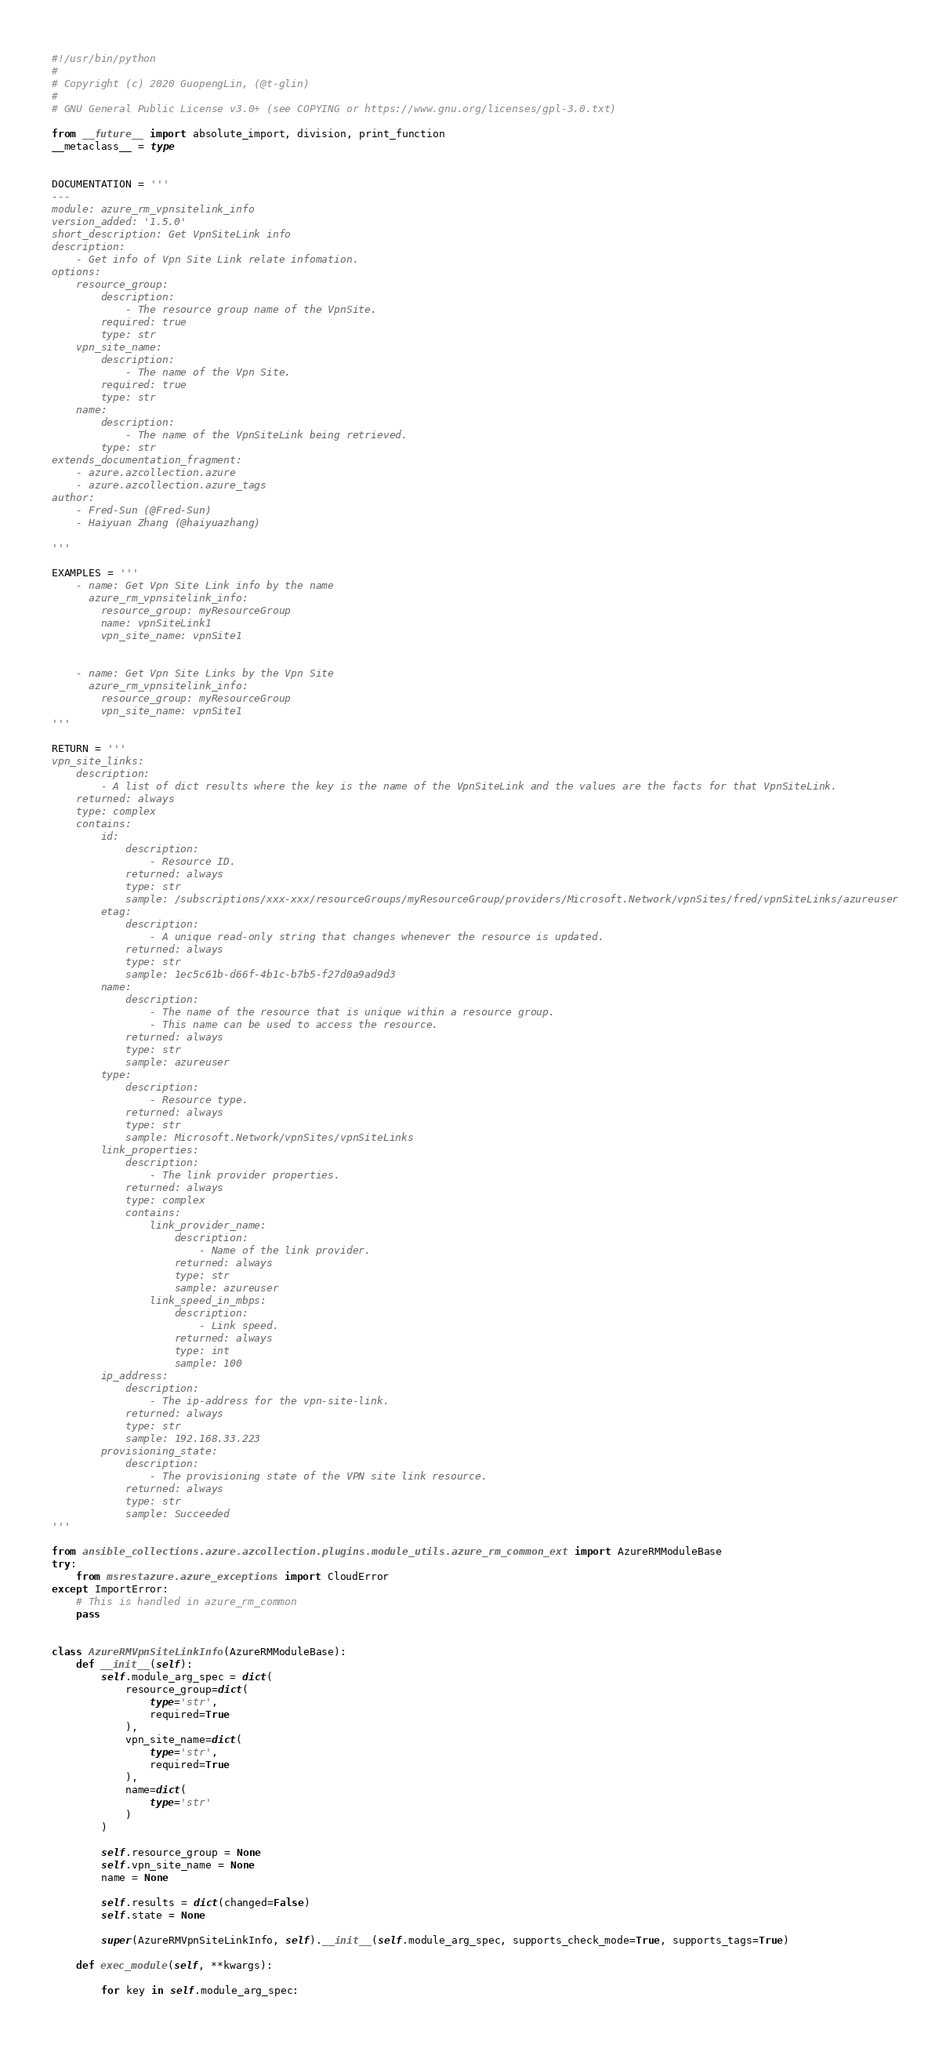<code> <loc_0><loc_0><loc_500><loc_500><_Python_>#!/usr/bin/python
#
# Copyright (c) 2020 GuopengLin, (@t-glin)
#
# GNU General Public License v3.0+ (see COPYING or https://www.gnu.org/licenses/gpl-3.0.txt)

from __future__ import absolute_import, division, print_function
__metaclass__ = type


DOCUMENTATION = '''
---
module: azure_rm_vpnsitelink_info
version_added: '1.5.0'
short_description: Get VpnSiteLink info
description:
    - Get info of Vpn Site Link relate infomation.
options:
    resource_group:
        description:
            - The resource group name of the VpnSite.
        required: true
        type: str
    vpn_site_name:
        description:
            - The name of the Vpn Site.
        required: true
        type: str
    name:
        description:
            - The name of the VpnSiteLink being retrieved.
        type: str
extends_documentation_fragment:
    - azure.azcollection.azure
    - azure.azcollection.azure_tags
author:
    - Fred-Sun (@Fred-Sun)
    - Haiyuan Zhang (@haiyuazhang)

'''

EXAMPLES = '''
    - name: Get Vpn Site Link info by the name
      azure_rm_vpnsitelink_info:
        resource_group: myResourceGroup
        name: vpnSiteLink1
        vpn_site_name: vpnSite1


    - name: Get Vpn Site Links by the Vpn Site
      azure_rm_vpnsitelink_info:
        resource_group: myResourceGroup
        vpn_site_name: vpnSite1
'''

RETURN = '''
vpn_site_links:
    description:
        - A list of dict results where the key is the name of the VpnSiteLink and the values are the facts for that VpnSiteLink.
    returned: always
    type: complex
    contains:
        id:
            description:
                - Resource ID.
            returned: always
            type: str
            sample: /subscriptions/xxx-xxx/resourceGroups/myResourceGroup/providers/Microsoft.Network/vpnSites/fred/vpnSiteLinks/azureuser
        etag:
            description:
                - A unique read-only string that changes whenever the resource is updated.
            returned: always
            type: str
            sample: 1ec5c61b-d66f-4b1c-b7b5-f27d0a9ad9d3
        name:
            description:
                - The name of the resource that is unique within a resource group.
                - This name can be used to access the resource.
            returned: always
            type: str
            sample: azureuser
        type:
            description:
                - Resource type.
            returned: always
            type: str
            sample: Microsoft.Network/vpnSites/vpnSiteLinks
        link_properties:
            description:
                - The link provider properties.
            returned: always
            type: complex
            contains:
                link_provider_name:
                    description:
                        - Name of the link provider.
                    returned: always
                    type: str
                    sample: azureuser
                link_speed_in_mbps:
                    description:
                        - Link speed.
                    returned: always
                    type: int
                    sample: 100
        ip_address:
            description:
                - The ip-address for the vpn-site-link.
            returned: always
            type: str
            sample: 192.168.33.223
        provisioning_state:
            description:
                - The provisioning state of the VPN site link resource.
            returned: always
            type: str
            sample: Succeeded
'''

from ansible_collections.azure.azcollection.plugins.module_utils.azure_rm_common_ext import AzureRMModuleBase
try:
    from msrestazure.azure_exceptions import CloudError
except ImportError:
    # This is handled in azure_rm_common
    pass


class AzureRMVpnSiteLinkInfo(AzureRMModuleBase):
    def __init__(self):
        self.module_arg_spec = dict(
            resource_group=dict(
                type='str',
                required=True
            ),
            vpn_site_name=dict(
                type='str',
                required=True
            ),
            name=dict(
                type='str'
            )
        )

        self.resource_group = None
        self.vpn_site_name = None
        name = None

        self.results = dict(changed=False)
        self.state = None

        super(AzureRMVpnSiteLinkInfo, self).__init__(self.module_arg_spec, supports_check_mode=True, supports_tags=True)

    def exec_module(self, **kwargs):

        for key in self.module_arg_spec:</code> 